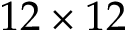Convert formula to latex. <formula><loc_0><loc_0><loc_500><loc_500>1 2 \times 1 2</formula> 